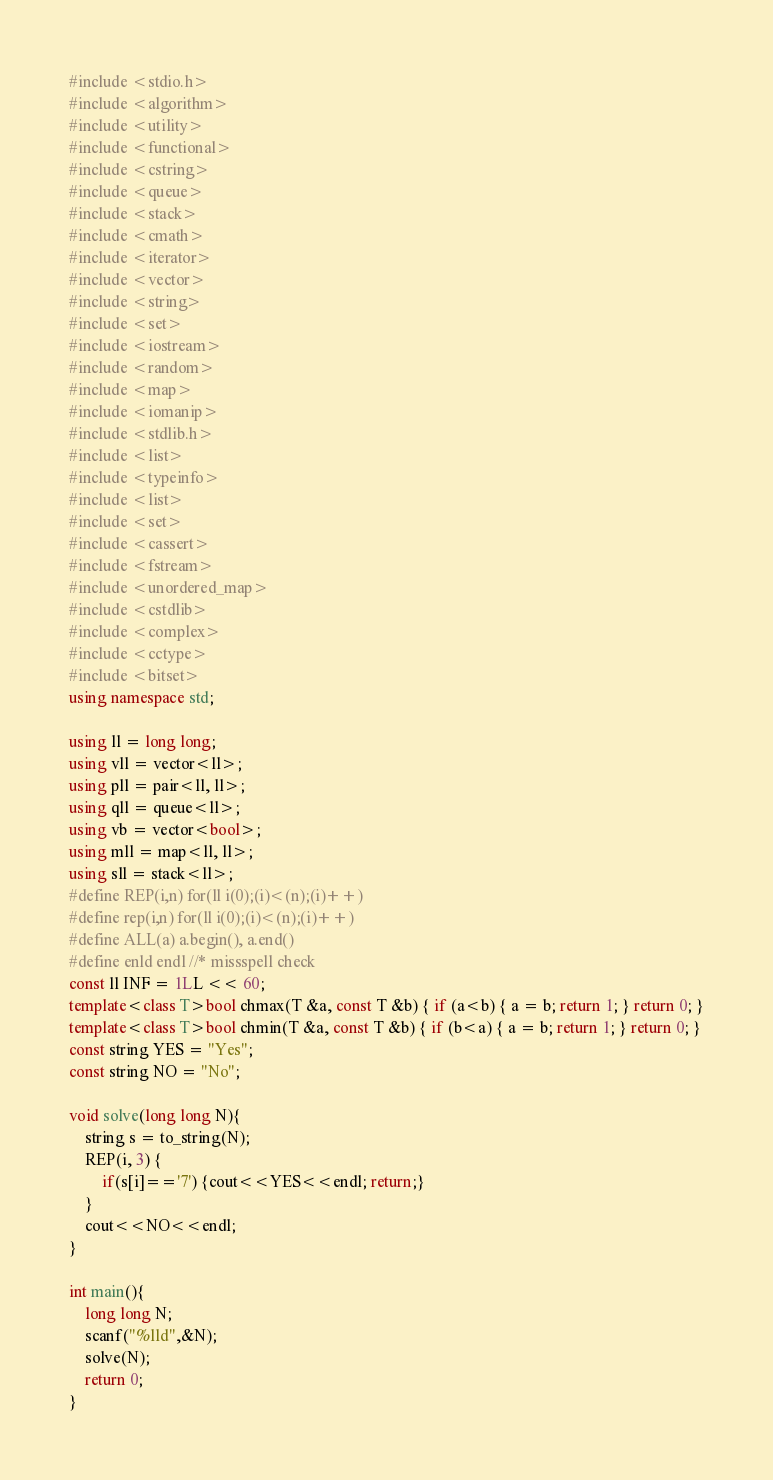<code> <loc_0><loc_0><loc_500><loc_500><_C++_>#include <stdio.h>
#include <algorithm>
#include <utility>
#include <functional>
#include <cstring>
#include <queue>
#include <stack>
#include <cmath>
#include <iterator>
#include <vector>
#include <string>
#include <set>
#include <iostream>
#include <random>
#include <map>
#include <iomanip>
#include <stdlib.h>
#include <list>
#include <typeinfo>
#include <list>
#include <set>
#include <cassert>
#include <fstream>
#include <unordered_map>
#include <cstdlib>
#include <complex>
#include <cctype>
#include <bitset>
using namespace std;

using ll = long long;
using vll = vector<ll>;
using pll = pair<ll, ll>;
using qll = queue<ll>;
using vb = vector<bool>;
using mll = map<ll, ll>;
using sll = stack<ll>;
#define REP(i,n) for(ll i(0);(i)<(n);(i)++)
#define rep(i,n) for(ll i(0);(i)<(n);(i)++)
#define ALL(a) a.begin(), a.end()
#define enld endl //* missspell check
const ll INF = 1LL << 60;
template<class T>bool chmax(T &a, const T &b) { if (a<b) { a = b; return 1; } return 0; }
template<class T>bool chmin(T &a, const T &b) { if (b<a) { a = b; return 1; } return 0; }
const string YES = "Yes";
const string NO = "No";

void solve(long long N){
    string s = to_string(N);
    REP(i, 3) {
        if(s[i]=='7') {cout<<YES<<endl; return;}
    }
    cout<<NO<<endl;
}

int main(){
    long long N;
    scanf("%lld",&N);
    solve(N);
    return 0;
}
</code> 